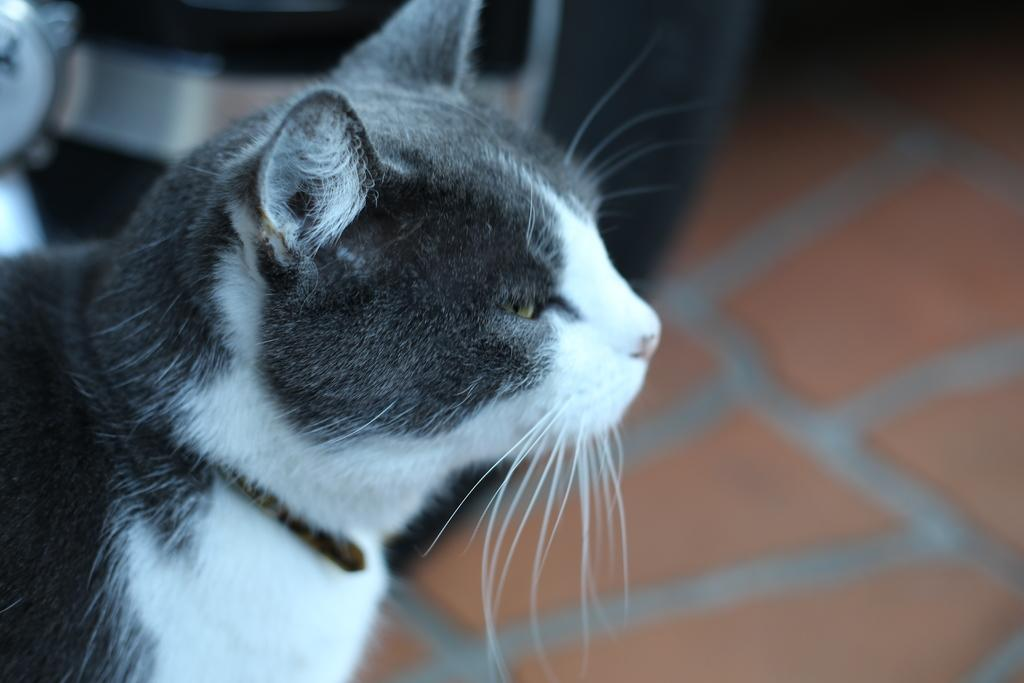What type of animal is in the picture? There is a cat in the picture. Can you describe the color pattern of the cat? The cat is white and black in color. What type of prison is the kitty trying to escape from in the picture? There is no prison or kitty present in the image; it features a cat that is white and black in color. 